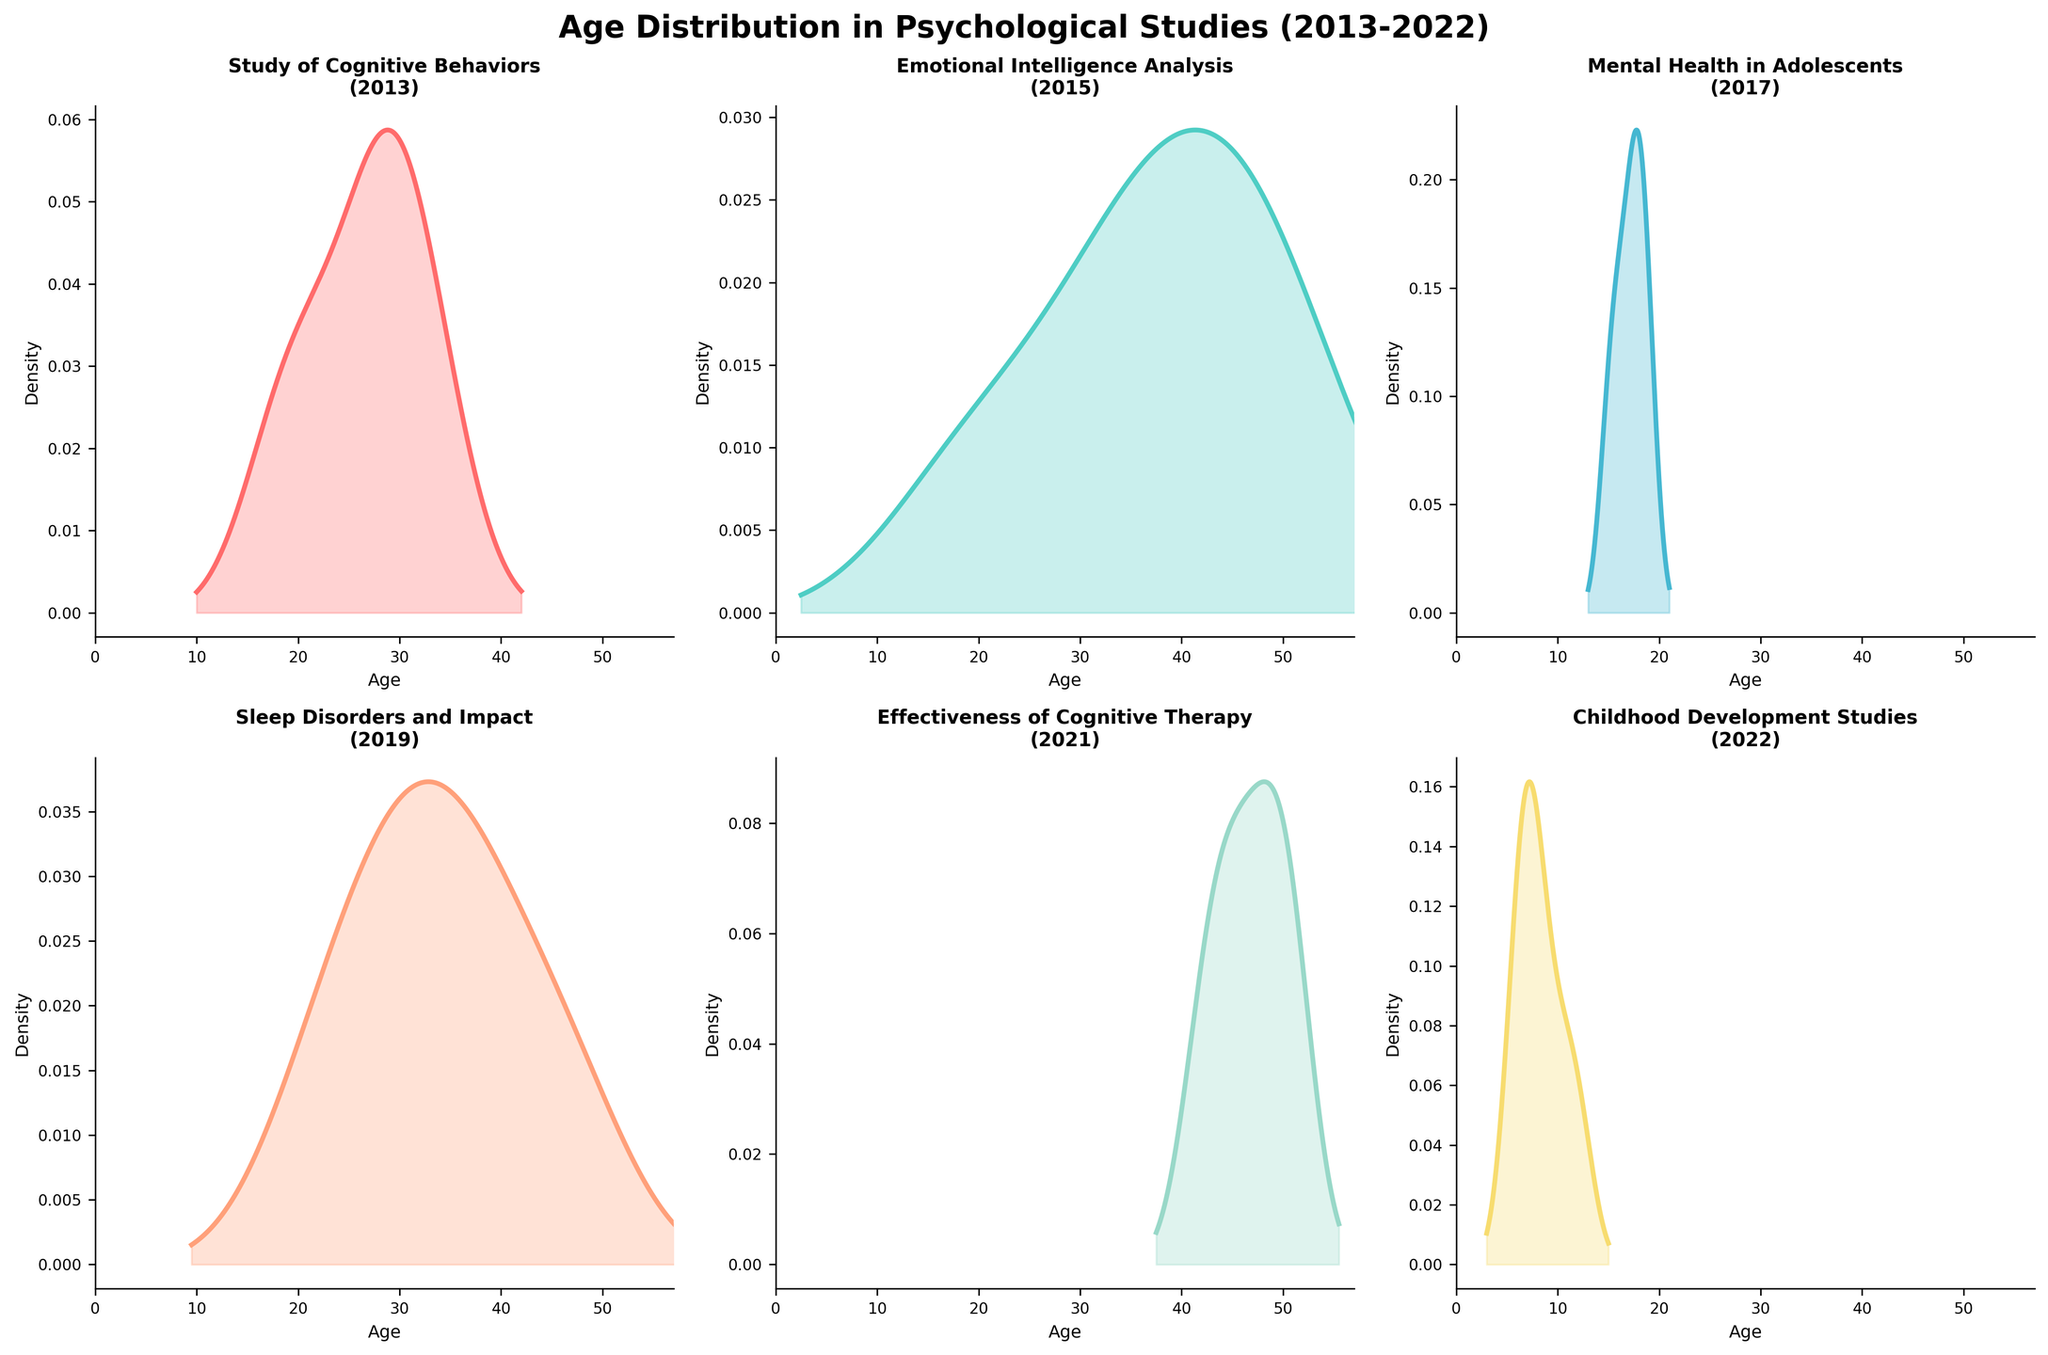What is the title of the figure? The title of the figure is displayed at the top and summarizes the content of the plots. It reads, "Age Distribution in Psychological Studies (2013-2022)."
Answer: Age Distribution in Psychological Studies (2013-2022) How many subplots are there in total? There are two rows and three columns of subplots, making a total of six subplots.
Answer: 6 Which study's age distribution is centered around the youngest age range? By observing the density plots, the "Childhood Development Studies" subplot shows the age distribution centered around the youngest ages, which is consistent with the ages of children.
Answer: Childhood Development Studies Which study has the widest spread (variation) in the age distribution? To determine the widest spread, observe the range the density plot covers along the x-axis. The "Effectiveness of Cognitive Therapy" plot shows ages ranging broadly, suggesting it has the widest age spread.
Answer: Effectiveness of Cognitive Therapy Which study has a density peak around the age 18? A density plot with a peak near age 18 indicates a higher concentration of participants around this age. The "Mental Health in Adolescents" plot shows this characteristic.
Answer: Mental Health in Adolescents Which of the subplots shows a bimodal distribution? A bimodal distribution indicates two peaks in the density plot. The "Emotional Intelligence Analysis" subplot displays two distinct peaks, suggesting a bimodal distribution.
Answer: Emotional Intelligence Analysis Compare the age distributions of "Study of Cognitive Behaviors" and "Sleep Disorders and Impact." Which one has a higher peak density? The height of the peak in the density plot indicates higher concentration. By comparing these subplots visually, "Sleep Disorders and Impact" has a higher peak density than "Study of Cognitive Behaviors."
Answer: Sleep Disorders and Impact Which study appears to have participants with the smallest maximum age? The maximum age can be observed at the end of the x-axis range on each density plot. The "Childhood Development Studies" plot has the smallest maximum age, around 12.
Answer: Childhood Development Studies What is the average peak age for the "Effectiveness of Cognitive Therapy"? The "Effectiveness of Cognitive Therapy" density plot shows a peak around 50. This value represents the average age for the study participants at the peak.
Answer: 50 